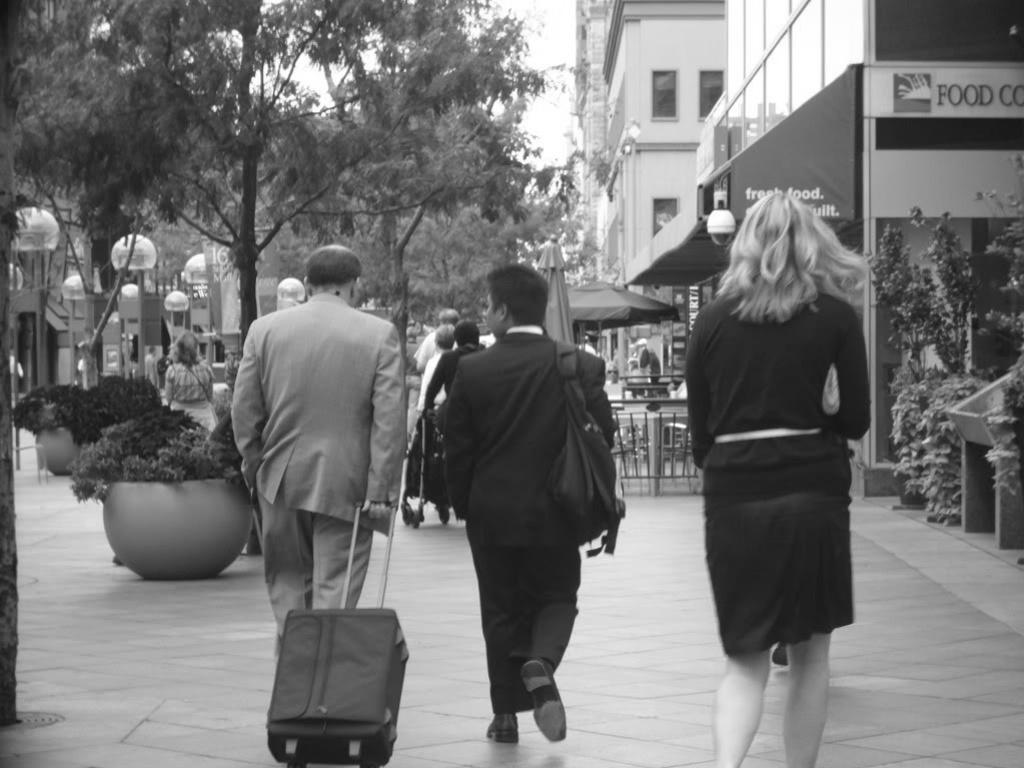What are the people in the image doing? The people in the image are walking on the road. What are the people carrying while walking? The people are carrying bags. What can be seen in the background of the image? There are buildings and a tree visible in the background. What features do the buildings have? The buildings have windows. What else can be seen in the background of the image? Lights are present in the background. How does the tramp affect the people walking on the road in the image? There is no tramp present in the image, so it does not affect the people walking on the road. 